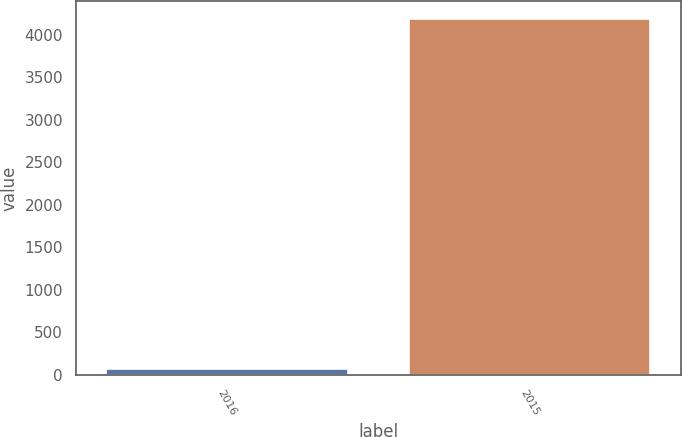Convert chart to OTSL. <chart><loc_0><loc_0><loc_500><loc_500><bar_chart><fcel>2016<fcel>2015<nl><fcel>72<fcel>4187<nl></chart> 